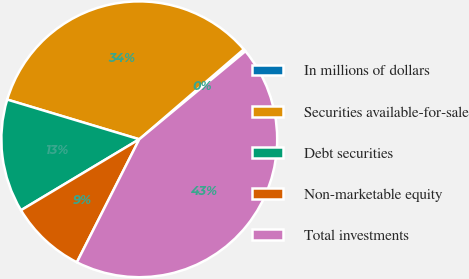Convert chart to OTSL. <chart><loc_0><loc_0><loc_500><loc_500><pie_chart><fcel>In millions of dollars<fcel>Securities available-for-sale<fcel>Debt securities<fcel>Non-marketable equity<fcel>Total investments<nl><fcel>0.29%<fcel>34.04%<fcel>13.25%<fcel>8.93%<fcel>43.5%<nl></chart> 